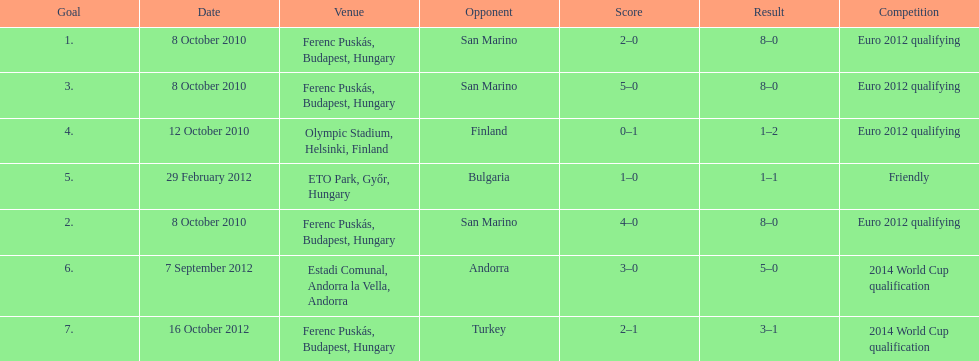In what year did ádám szalai make his next international goal after 2010? 2012. 